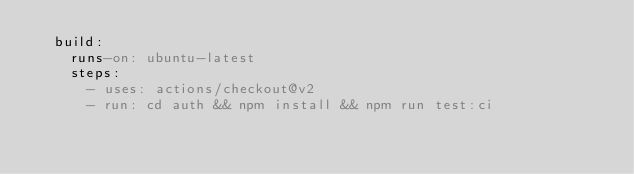<code> <loc_0><loc_0><loc_500><loc_500><_YAML_>  build:
    runs-on: ubuntu-latest
    steps:
      - uses: actions/checkout@v2
      - run: cd auth && npm install && npm run test:ci
</code> 